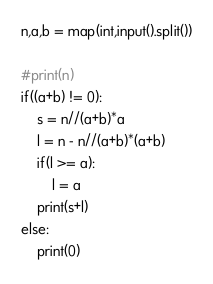<code> <loc_0><loc_0><loc_500><loc_500><_Python_>n,a,b = map(int,input().split())

#print(n)
if((a+b) != 0):
    s = n//(a+b)*a
    l = n - n//(a+b)*(a+b)
    if(l >= a):
        l = a
    print(s+l)
else:
    print(0)
</code> 